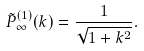<formula> <loc_0><loc_0><loc_500><loc_500>\tilde { P } ^ { ( 1 ) } _ { \infty } ( k ) = \frac { 1 } { \sqrt { 1 + k ^ { 2 } } } .</formula> 